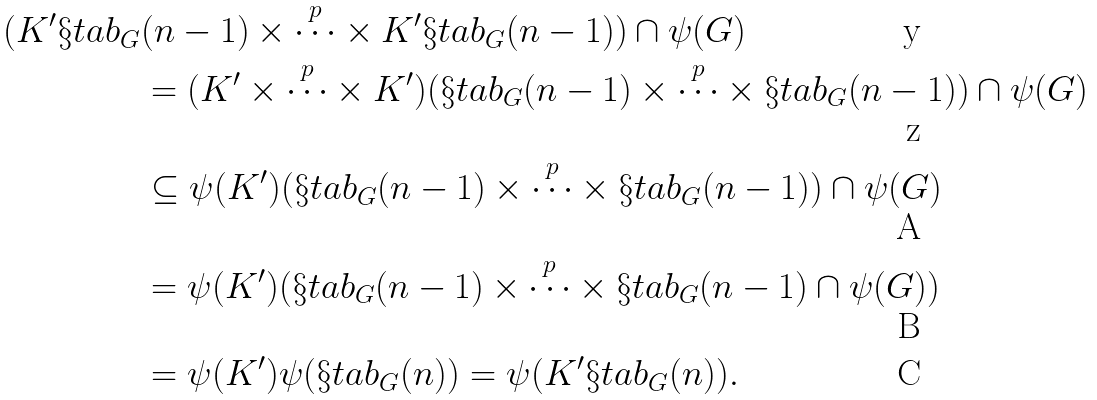Convert formula to latex. <formula><loc_0><loc_0><loc_500><loc_500>( K ^ { \prime } \S t a b _ { G } & ( n - 1 ) \times \overset { p } { \cdots } \times K ^ { \prime } \S t a b _ { G } ( n - 1 ) ) \cap \psi ( G ) \\ & = ( K ^ { \prime } \times \overset { p } { \cdots } \times K ^ { \prime } ) ( \S t a b _ { G } ( n - 1 ) \times \overset { p } { \cdots } \times \S t a b _ { G } ( n - 1 ) ) \cap \psi ( G ) \\ & \subseteq \psi ( K ^ { \prime } ) ( \S t a b _ { G } ( n - 1 ) \times \overset { p } { \cdots } \times \S t a b _ { G } ( n - 1 ) ) \cap \psi ( G ) \\ & = \psi ( K ^ { \prime } ) ( \S t a b _ { G } ( n - 1 ) \times \overset { p } { \cdots } \times \S t a b _ { G } ( n - 1 ) \cap \psi ( G ) ) \\ & = \psi ( K ^ { \prime } ) \psi ( \S t a b _ { G } ( n ) ) = \psi ( K ^ { \prime } \S t a b _ { G } ( n ) ) .</formula> 